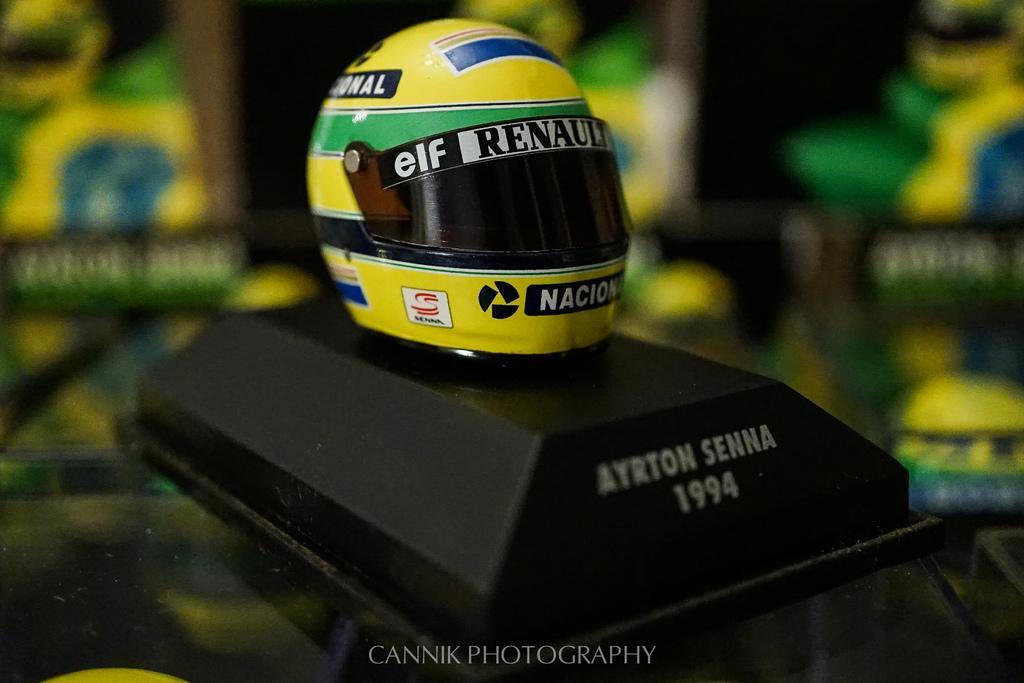In one or two sentences, can you explain what this image depicts? In this image, we can see a helmet, placed on the stand. 